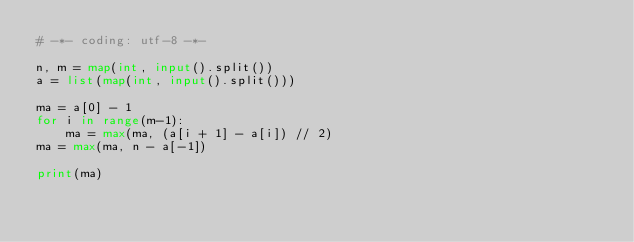Convert code to text. <code><loc_0><loc_0><loc_500><loc_500><_Python_># -*- coding: utf-8 -*-

n, m = map(int, input().split())
a = list(map(int, input().split()))

ma = a[0] - 1
for i in range(m-1):
    ma = max(ma, (a[i + 1] - a[i]) // 2)
ma = max(ma, n - a[-1])

print(ma)</code> 